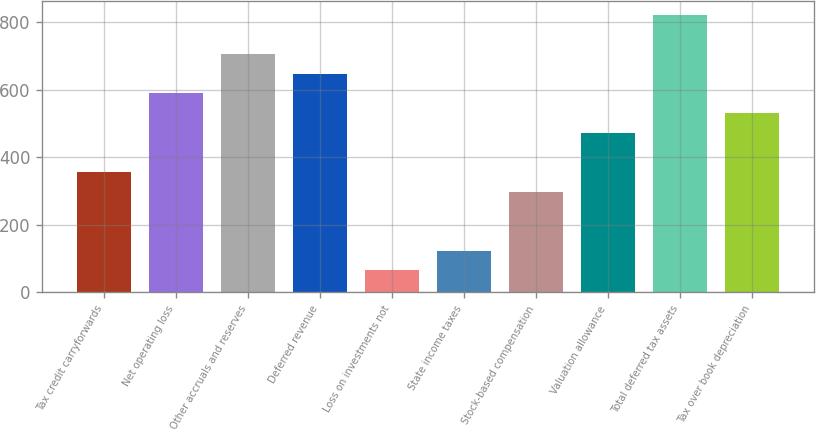Convert chart. <chart><loc_0><loc_0><loc_500><loc_500><bar_chart><fcel>Tax credit carryforwards<fcel>Net operating loss<fcel>Other accruals and reserves<fcel>Deferred revenue<fcel>Loss on investments not<fcel>State income taxes<fcel>Stock-based compensation<fcel>Valuation allowance<fcel>Total deferred tax assets<fcel>Tax over book depreciation<nl><fcel>356.2<fcel>589<fcel>705.4<fcel>647.2<fcel>65.2<fcel>123.4<fcel>298<fcel>472.6<fcel>821.8<fcel>530.8<nl></chart> 